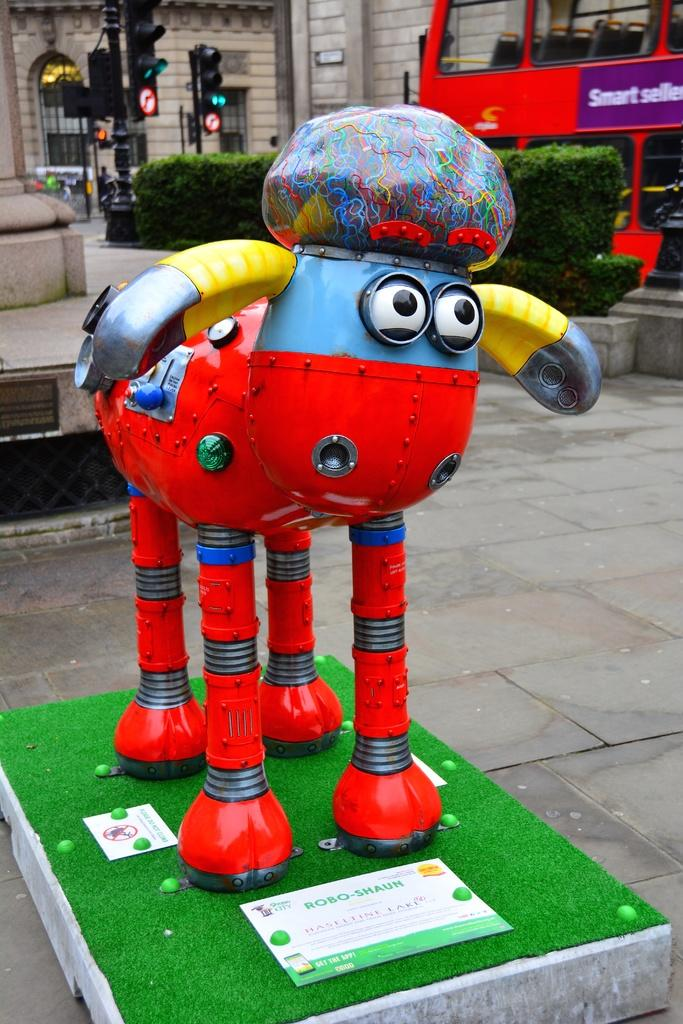What is the color of the object in the image? The object in the image is red. Where is the red object placed? The red object is on a greenery surface. What can be seen in the right corner of the image? There is a double-decker bus in the right corner of the image. What is visible in the background of the image? There are traffic signals and a building in the background of the image. What is the acoustics like in the image? The image does not provide information about the acoustics, as it is a still image and does not convey sound. What is the income of the people in the image? There is no information about the income of the people in the image, as it only shows objects and not individuals. 